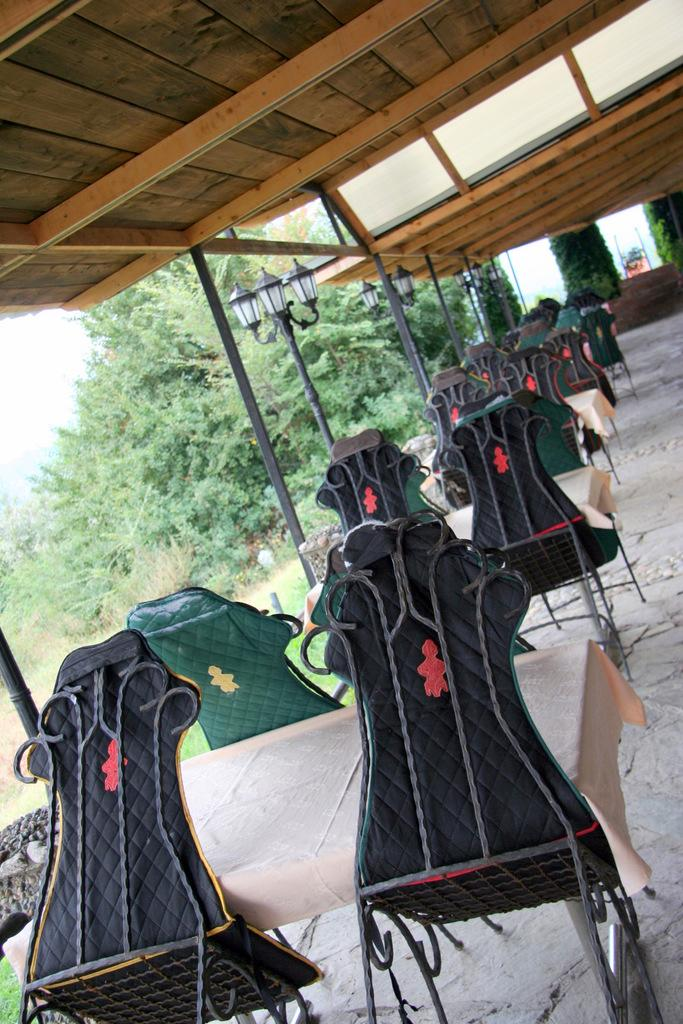What type of furniture is present in the image? There are tables and chairs in the image. What is placed on the tables? There are cream-colored clothes on the tables. What can be seen in the background of the image? There are trees and the sky visible in the background of the image. What type of record can be seen spinning on one of the tables in the image? There is no record present in the image; only tables, chairs, cream-colored clothes, trees, and the sky are visible. 